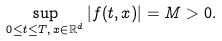Convert formula to latex. <formula><loc_0><loc_0><loc_500><loc_500>\sup _ { 0 \leq t \leq T , \, x \in \mathbb { R } ^ { d } } | f ( t , x ) | = M > 0 .</formula> 